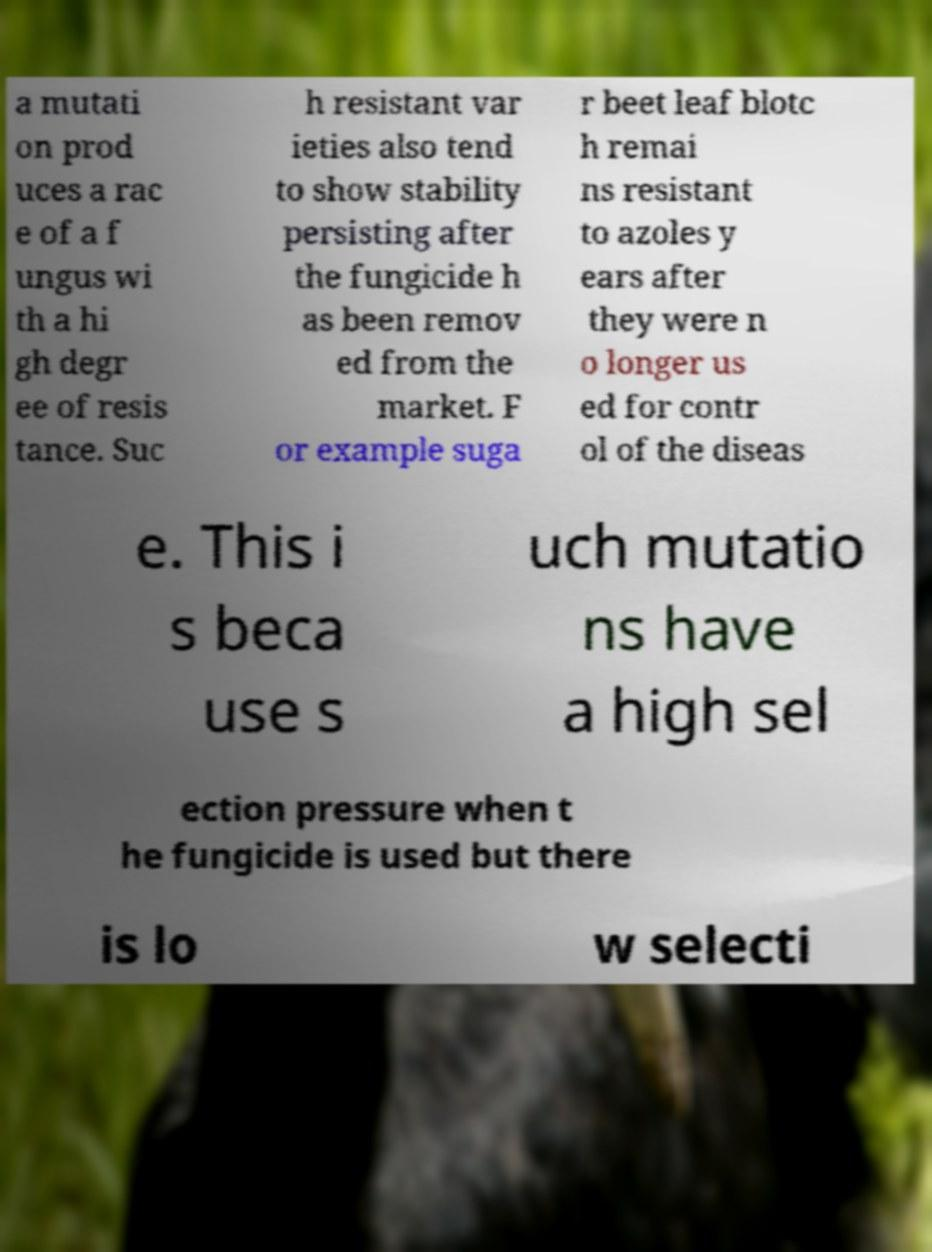Can you read and provide the text displayed in the image?This photo seems to have some interesting text. Can you extract and type it out for me? a mutati on prod uces a rac e of a f ungus wi th a hi gh degr ee of resis tance. Suc h resistant var ieties also tend to show stability persisting after the fungicide h as been remov ed from the market. F or example suga r beet leaf blotc h remai ns resistant to azoles y ears after they were n o longer us ed for contr ol of the diseas e. This i s beca use s uch mutatio ns have a high sel ection pressure when t he fungicide is used but there is lo w selecti 